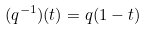Convert formula to latex. <formula><loc_0><loc_0><loc_500><loc_500>( q ^ { - 1 } ) ( t ) = q ( 1 - t )</formula> 